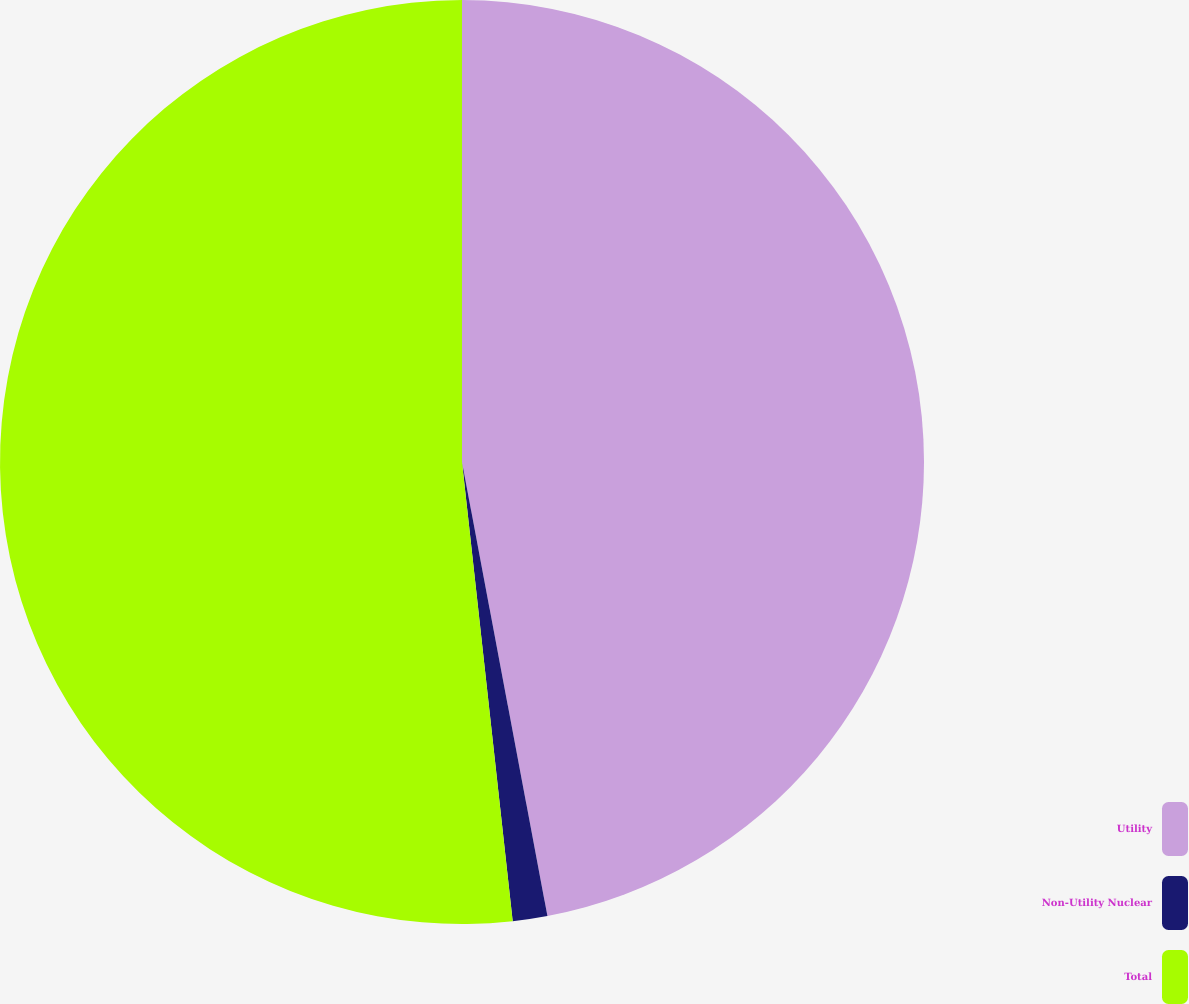Convert chart to OTSL. <chart><loc_0><loc_0><loc_500><loc_500><pie_chart><fcel>Utility<fcel>Non-Utility Nuclear<fcel>Total<nl><fcel>47.04%<fcel>1.21%<fcel>51.75%<nl></chart> 